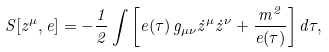<formula> <loc_0><loc_0><loc_500><loc_500>S [ z ^ { \mu } , e ] = - \frac { 1 } { 2 } \int \left [ e ( \tau ) \, g _ { \mu \nu } \dot { z } ^ { \mu } \dot { z } ^ { \nu } + \frac { m ^ { 2 } } { e ( \tau ) } \right ] d \tau ,</formula> 